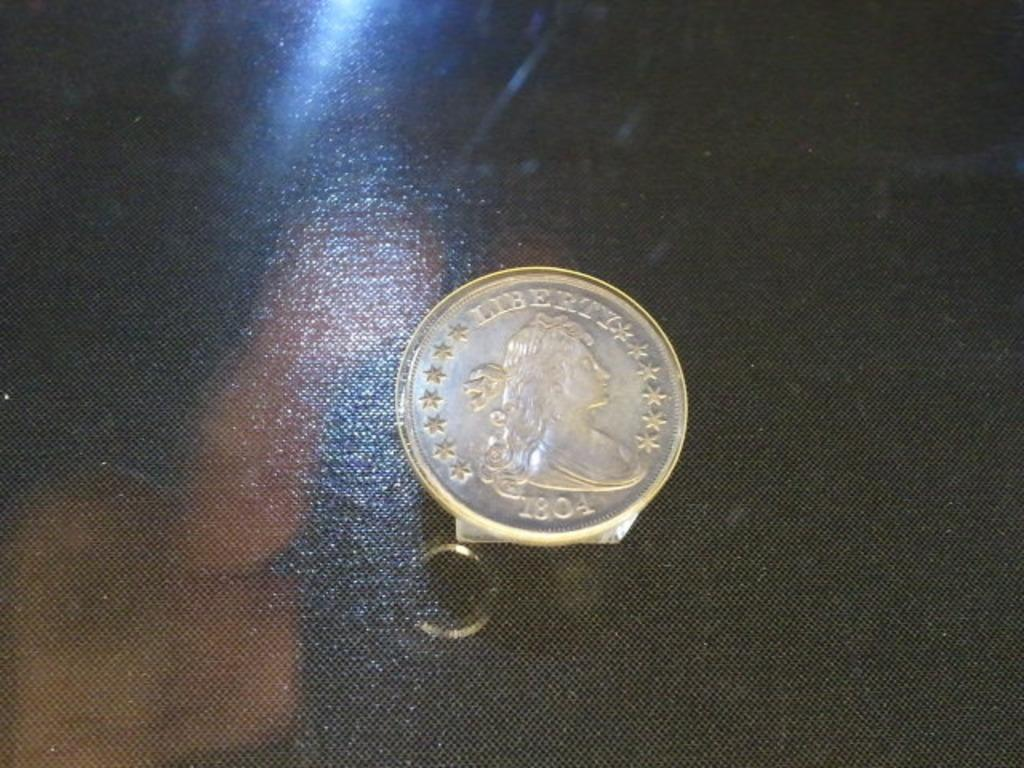<image>
Relay a brief, clear account of the picture shown. an old coin on display reading Liberty 1804 